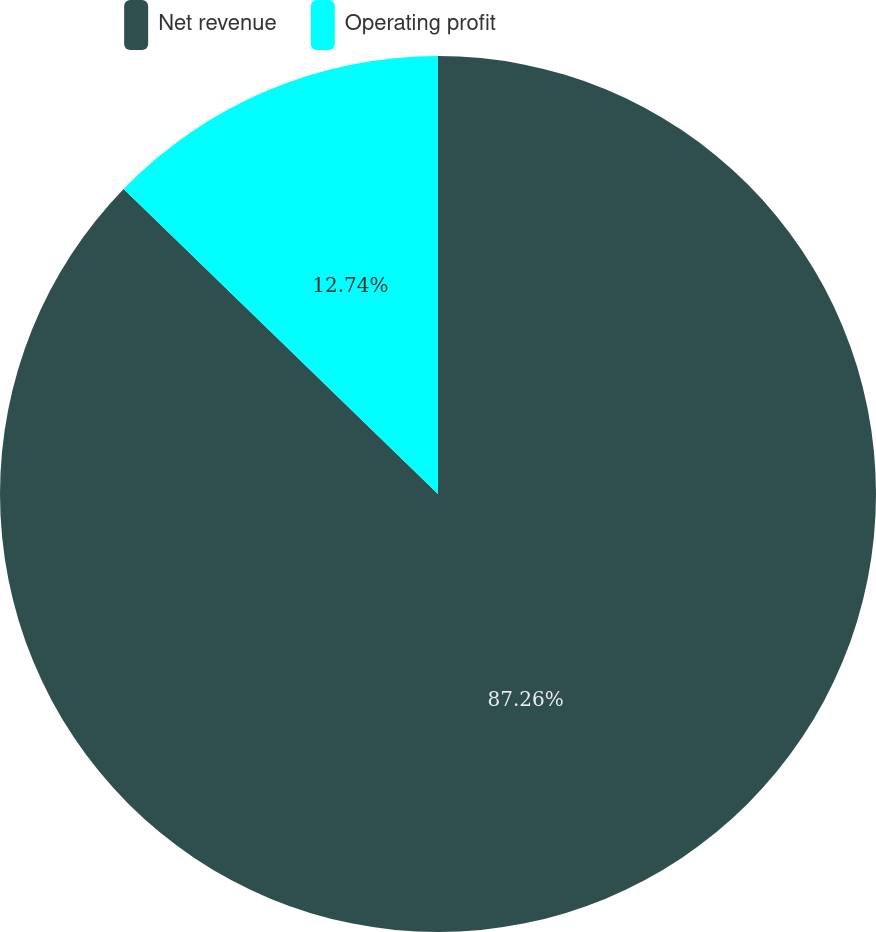Convert chart. <chart><loc_0><loc_0><loc_500><loc_500><pie_chart><fcel>Net revenue<fcel>Operating profit<nl><fcel>87.26%<fcel>12.74%<nl></chart> 